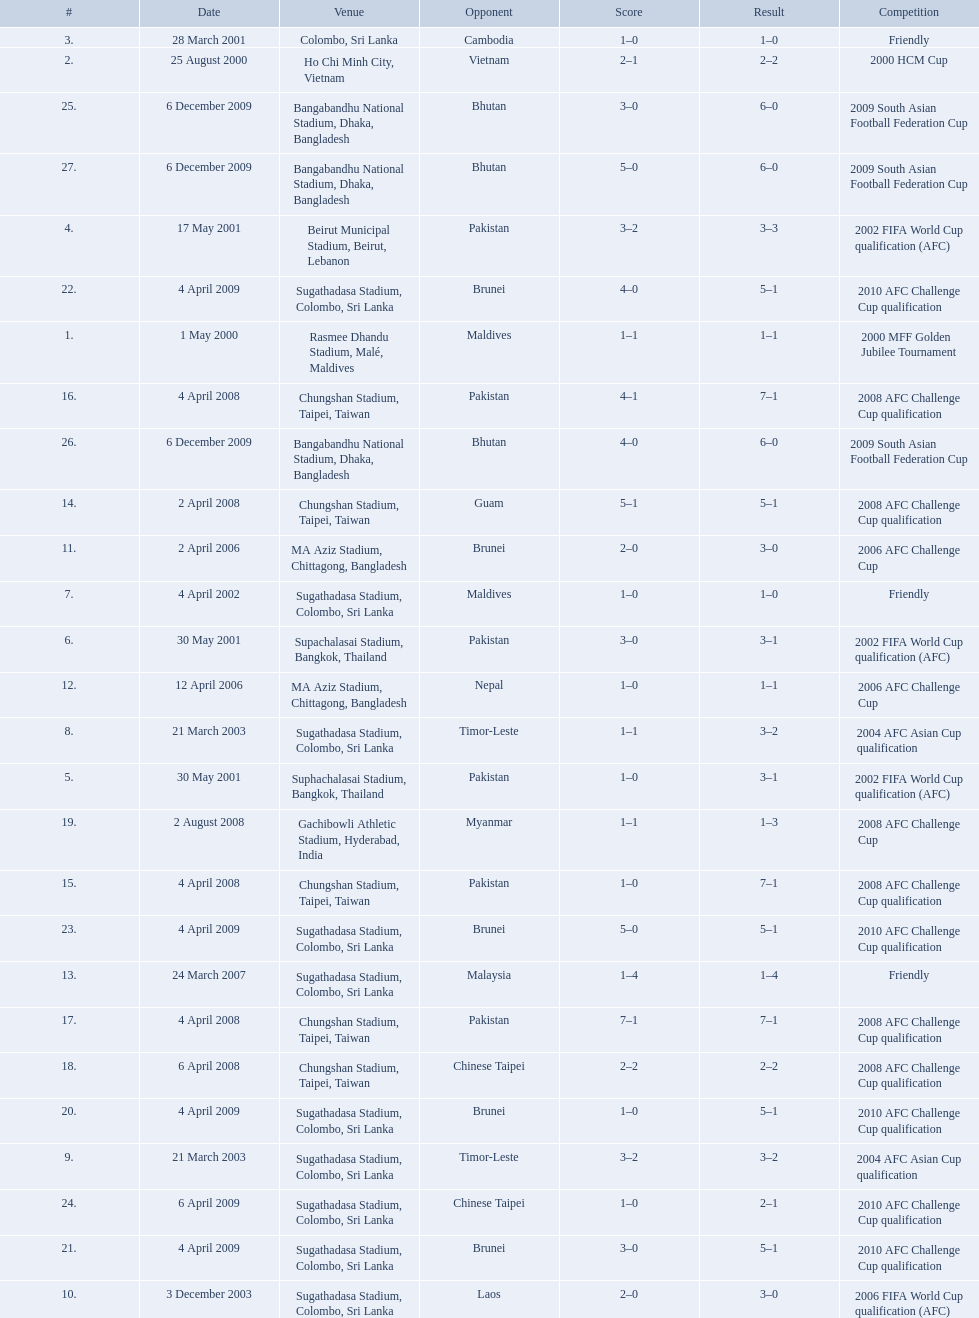What venues are listed? Rasmee Dhandu Stadium, Malé, Maldives, Ho Chi Minh City, Vietnam, Colombo, Sri Lanka, Beirut Municipal Stadium, Beirut, Lebanon, Suphachalasai Stadium, Bangkok, Thailand, MA Aziz Stadium, Chittagong, Bangladesh, Sugathadasa Stadium, Colombo, Sri Lanka, Chungshan Stadium, Taipei, Taiwan, Gachibowli Athletic Stadium, Hyderabad, India, Sugathadasa Stadium, Colombo, Sri Lanka, Bangabandhu National Stadium, Dhaka, Bangladesh. Which is top listed? Rasmee Dhandu Stadium, Malé, Maldives. 